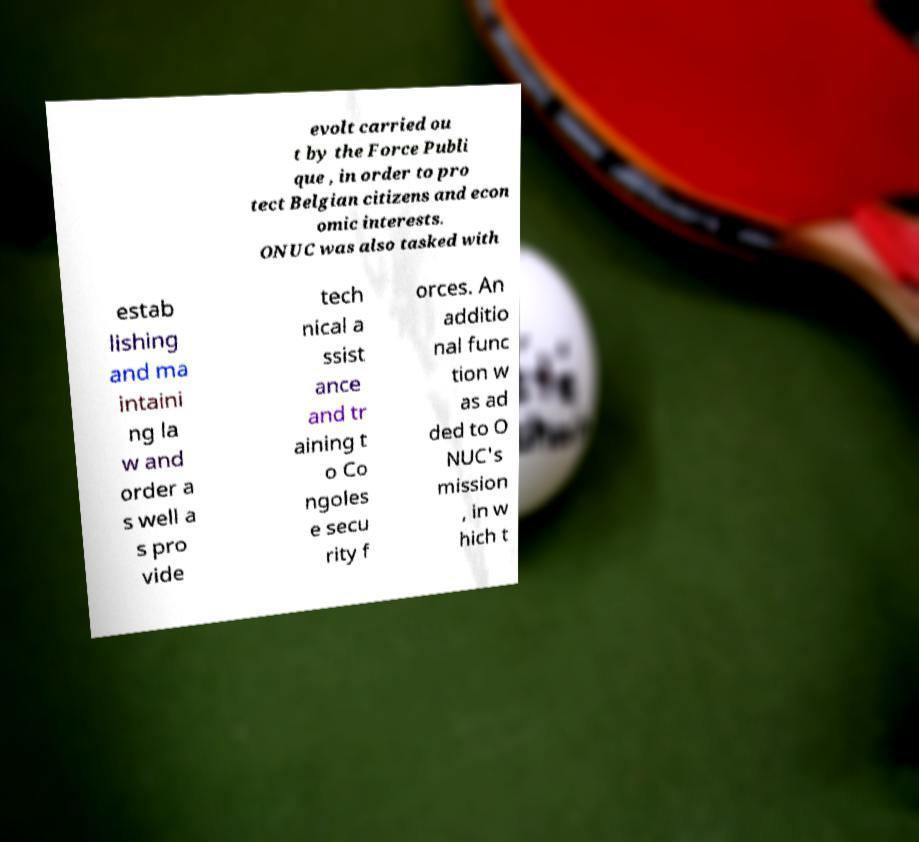Please read and relay the text visible in this image. What does it say? evolt carried ou t by the Force Publi que , in order to pro tect Belgian citizens and econ omic interests. ONUC was also tasked with estab lishing and ma intaini ng la w and order a s well a s pro vide tech nical a ssist ance and tr aining t o Co ngoles e secu rity f orces. An additio nal func tion w as ad ded to O NUC's mission , in w hich t 